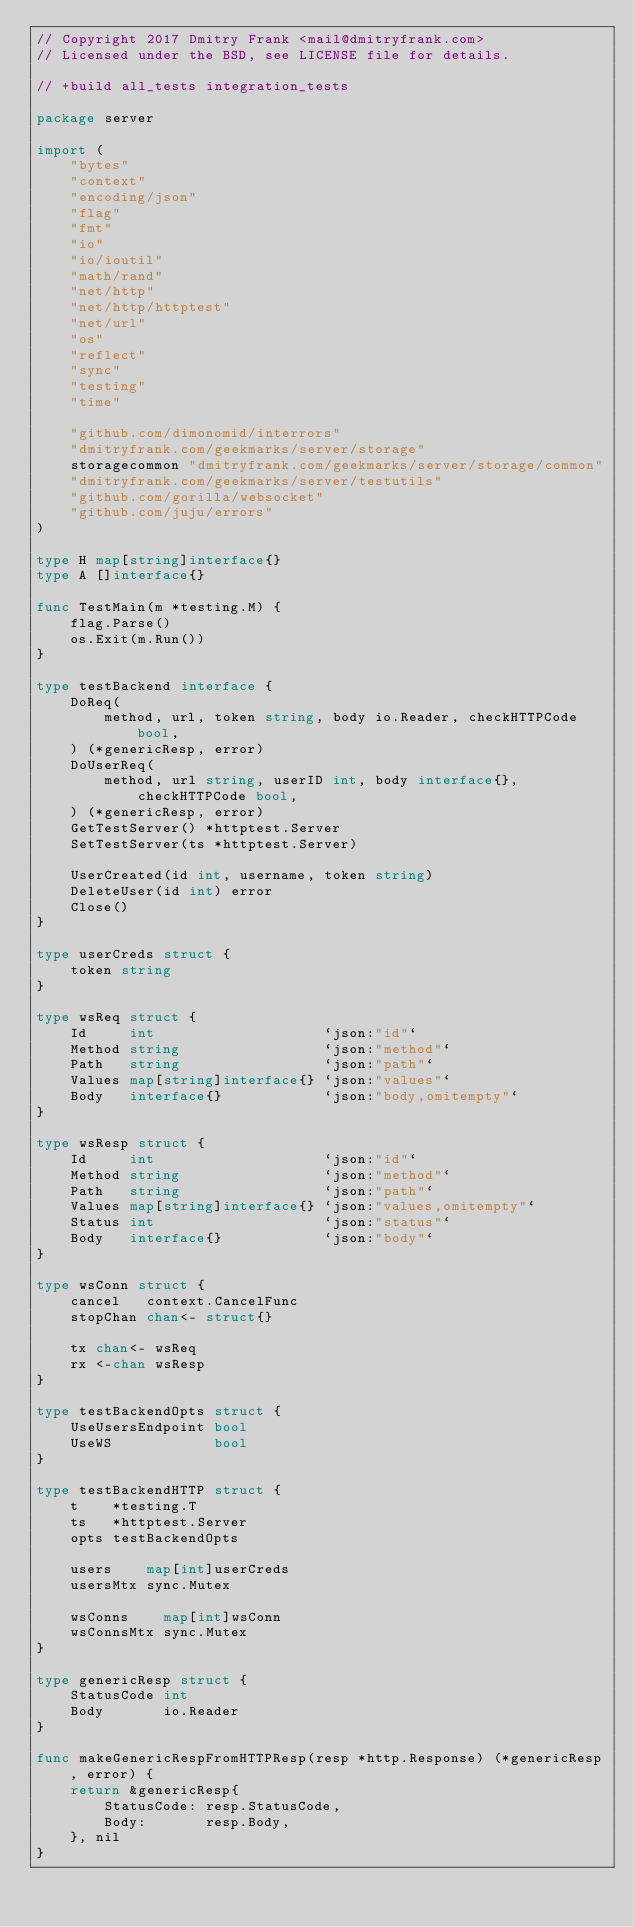Convert code to text. <code><loc_0><loc_0><loc_500><loc_500><_Go_>// Copyright 2017 Dmitry Frank <mail@dmitryfrank.com>
// Licensed under the BSD, see LICENSE file for details.

// +build all_tests integration_tests

package server

import (
	"bytes"
	"context"
	"encoding/json"
	"flag"
	"fmt"
	"io"
	"io/ioutil"
	"math/rand"
	"net/http"
	"net/http/httptest"
	"net/url"
	"os"
	"reflect"
	"sync"
	"testing"
	"time"

	"github.com/dimonomid/interrors"
	"dmitryfrank.com/geekmarks/server/storage"
	storagecommon "dmitryfrank.com/geekmarks/server/storage/common"
	"dmitryfrank.com/geekmarks/server/testutils"
	"github.com/gorilla/websocket"
	"github.com/juju/errors"
)

type H map[string]interface{}
type A []interface{}

func TestMain(m *testing.M) {
	flag.Parse()
	os.Exit(m.Run())
}

type testBackend interface {
	DoReq(
		method, url, token string, body io.Reader, checkHTTPCode bool,
	) (*genericResp, error)
	DoUserReq(
		method, url string, userID int, body interface{}, checkHTTPCode bool,
	) (*genericResp, error)
	GetTestServer() *httptest.Server
	SetTestServer(ts *httptest.Server)

	UserCreated(id int, username, token string)
	DeleteUser(id int) error
	Close()
}

type userCreds struct {
	token string
}

type wsReq struct {
	Id     int                    `json:"id"`
	Method string                 `json:"method"`
	Path   string                 `json:"path"`
	Values map[string]interface{} `json:"values"`
	Body   interface{}            `json:"body,omitempty"`
}

type wsResp struct {
	Id     int                    `json:"id"`
	Method string                 `json:"method"`
	Path   string                 `json:"path"`
	Values map[string]interface{} `json:"values,omitempty"`
	Status int                    `json:"status"`
	Body   interface{}            `json:"body"`
}

type wsConn struct {
	cancel   context.CancelFunc
	stopChan chan<- struct{}

	tx chan<- wsReq
	rx <-chan wsResp
}

type testBackendOpts struct {
	UseUsersEndpoint bool
	UseWS            bool
}

type testBackendHTTP struct {
	t    *testing.T
	ts   *httptest.Server
	opts testBackendOpts

	users    map[int]userCreds
	usersMtx sync.Mutex

	wsConns    map[int]wsConn
	wsConnsMtx sync.Mutex
}

type genericResp struct {
	StatusCode int
	Body       io.Reader
}

func makeGenericRespFromHTTPResp(resp *http.Response) (*genericResp, error) {
	return &genericResp{
		StatusCode: resp.StatusCode,
		Body:       resp.Body,
	}, nil
}
</code> 